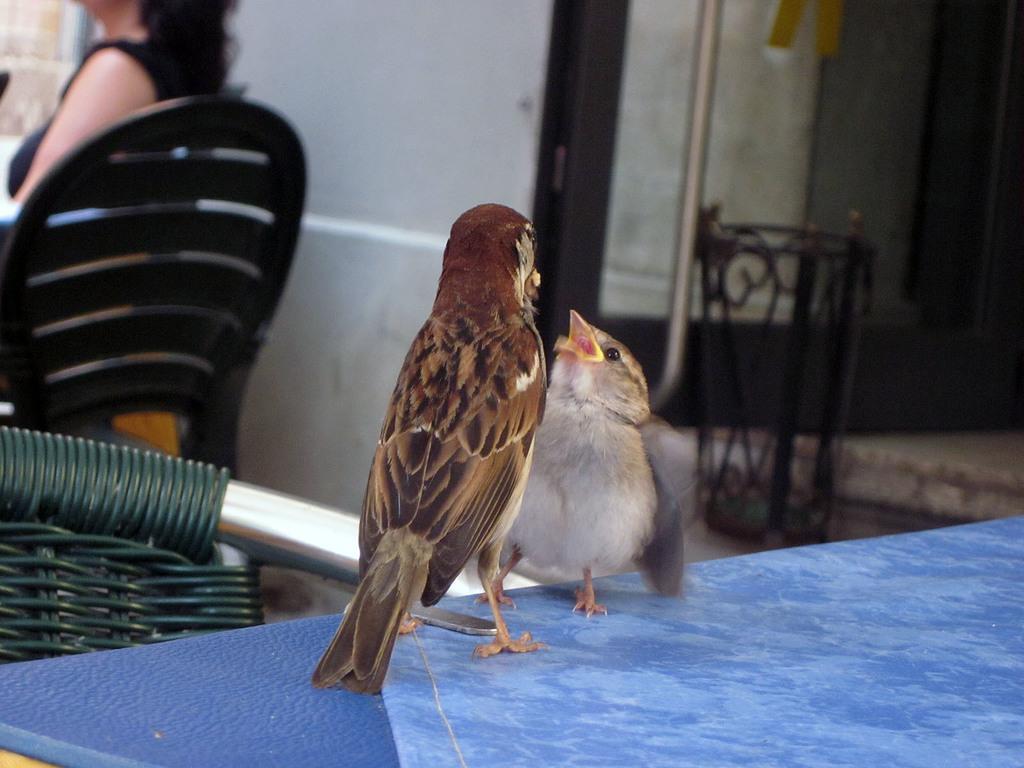How would you summarize this image in a sentence or two? In this image in the foreground there are two birds, at the bottom there is a table and chair. And in the background there is one woman who is sitting on a chair and wall, pole and some objects. 